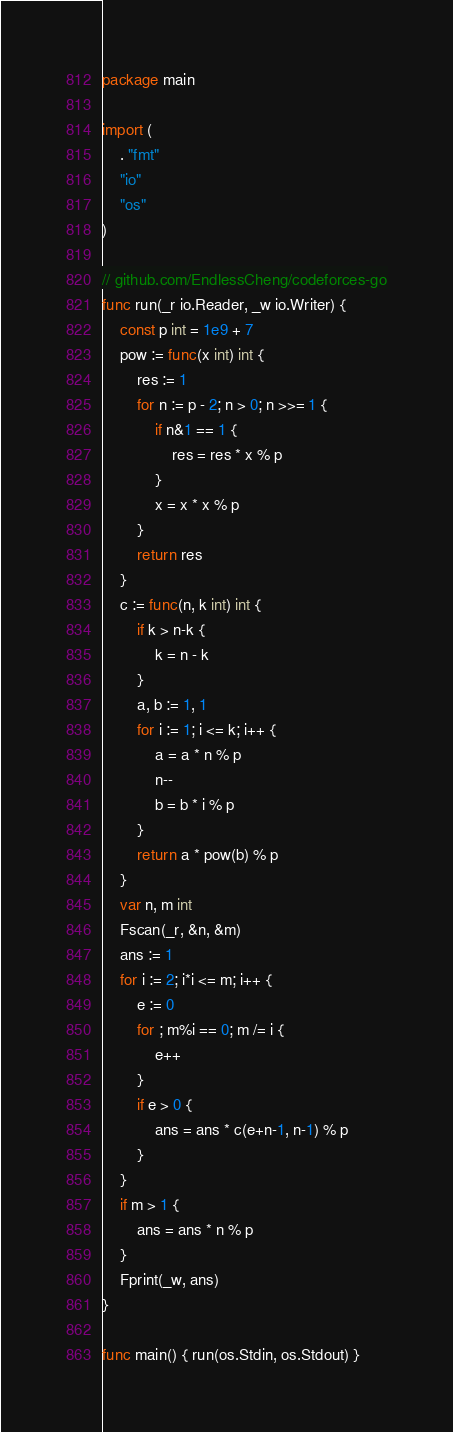Convert code to text. <code><loc_0><loc_0><loc_500><loc_500><_Go_>package main

import (
	. "fmt"
	"io"
	"os"
)

// github.com/EndlessCheng/codeforces-go
func run(_r io.Reader, _w io.Writer) {
	const p int = 1e9 + 7
	pow := func(x int) int {
		res := 1
		for n := p - 2; n > 0; n >>= 1 {
			if n&1 == 1 {
				res = res * x % p
			}
			x = x * x % p
		}
		return res
	}
	c := func(n, k int) int {
		if k > n-k {
			k = n - k
		}
		a, b := 1, 1
		for i := 1; i <= k; i++ {
			a = a * n % p
			n--
			b = b * i % p
		}
		return a * pow(b) % p
	}
	var n, m int
	Fscan(_r, &n, &m)
	ans := 1
	for i := 2; i*i <= m; i++ {
		e := 0
		for ; m%i == 0; m /= i {
			e++
		}
		if e > 0 {
			ans = ans * c(e+n-1, n-1) % p
		}
	}
	if m > 1 {
		ans = ans * n % p
	}
	Fprint(_w, ans)
}

func main() { run(os.Stdin, os.Stdout) }
</code> 